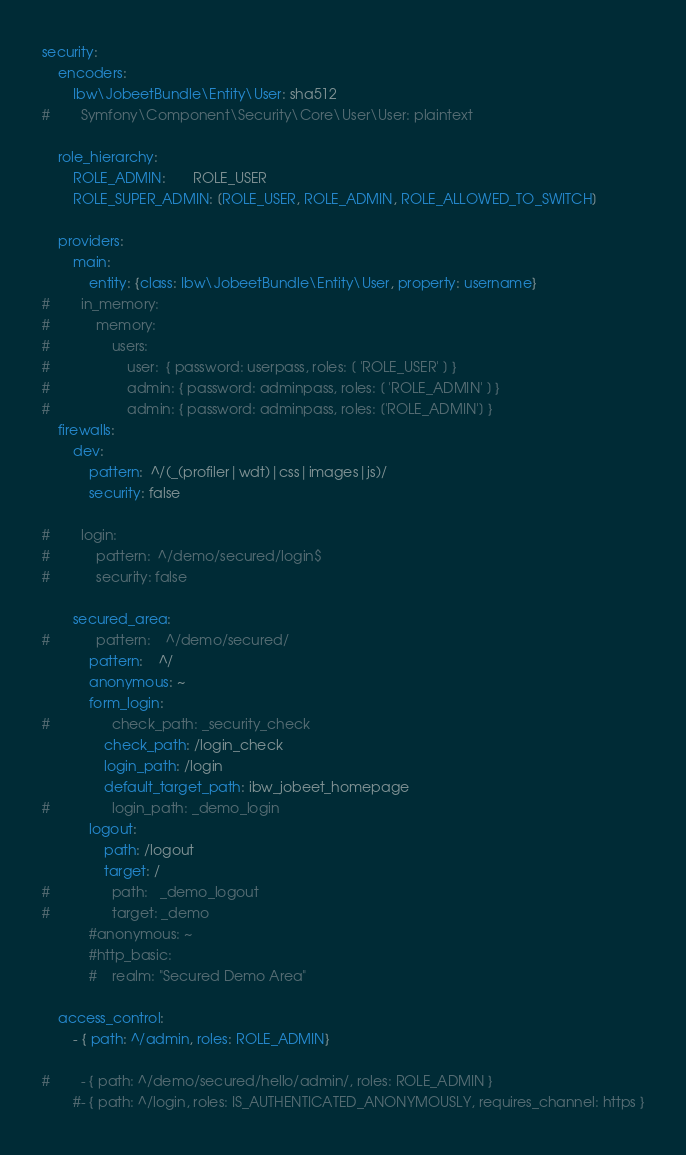<code> <loc_0><loc_0><loc_500><loc_500><_YAML_>security:
    encoders:
        Ibw\JobeetBundle\Entity\User: sha512
#        Symfony\Component\Security\Core\User\User: plaintext

    role_hierarchy:
        ROLE_ADMIN:       ROLE_USER
        ROLE_SUPER_ADMIN: [ROLE_USER, ROLE_ADMIN, ROLE_ALLOWED_TO_SWITCH]

    providers:
        main:
            entity: {class: Ibw\JobeetBundle\Entity\User, property: username}
#        in_memory:
#            memory:
#                users:
#                    user:  { password: userpass, roles: [ 'ROLE_USER' ] }
#                    admin: { password: adminpass, roles: [ 'ROLE_ADMIN' ] }
#                    admin: { password: adminpass, roles: ['ROLE_ADMIN'] }
    firewalls:
        dev:
            pattern:  ^/(_(profiler|wdt)|css|images|js)/
            security: false

#        login:
#            pattern:  ^/demo/secured/login$
#            security: false

        secured_area:
#            pattern:    ^/demo/secured/
            pattern:    ^/
            anonymous: ~
            form_login:
#                check_path: _security_check
                check_path: /login_check
                login_path: /login
                default_target_path: ibw_jobeet_homepage
#                login_path: _demo_login
            logout:
                path: /logout
                target: /
#                path:   _demo_logout
#                target: _demo
            #anonymous: ~
            #http_basic:
            #    realm: "Secured Demo Area"

    access_control:
        - { path: ^/admin, roles: ROLE_ADMIN}

#        - { path: ^/demo/secured/hello/admin/, roles: ROLE_ADMIN }
        #- { path: ^/login, roles: IS_AUTHENTICATED_ANONYMOUSLY, requires_channel: https }
</code> 